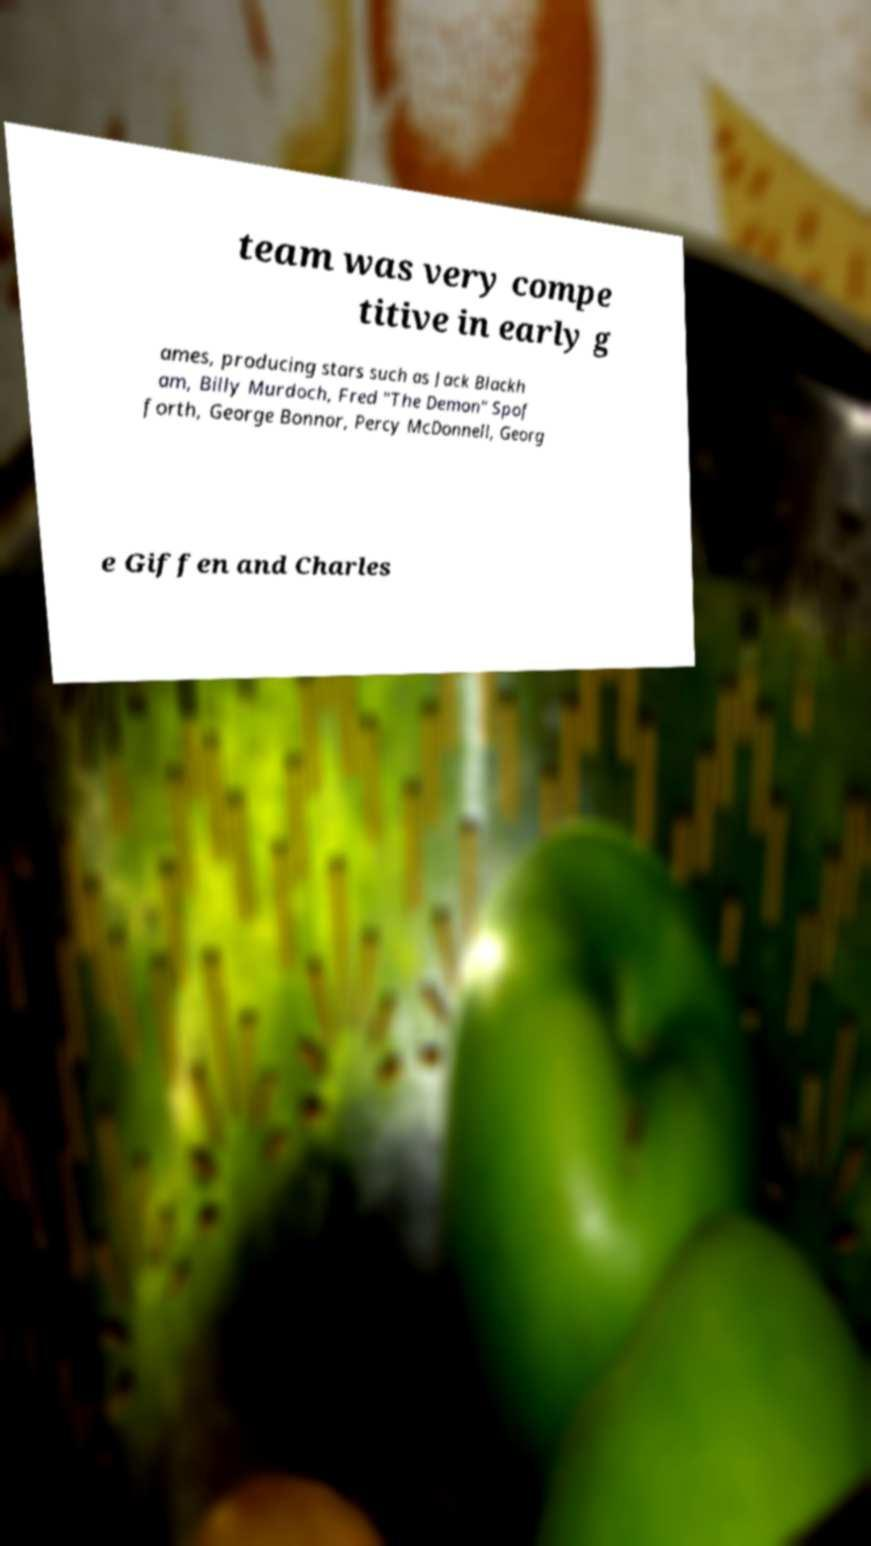Please identify and transcribe the text found in this image. team was very compe titive in early g ames, producing stars such as Jack Blackh am, Billy Murdoch, Fred "The Demon" Spof forth, George Bonnor, Percy McDonnell, Georg e Giffen and Charles 